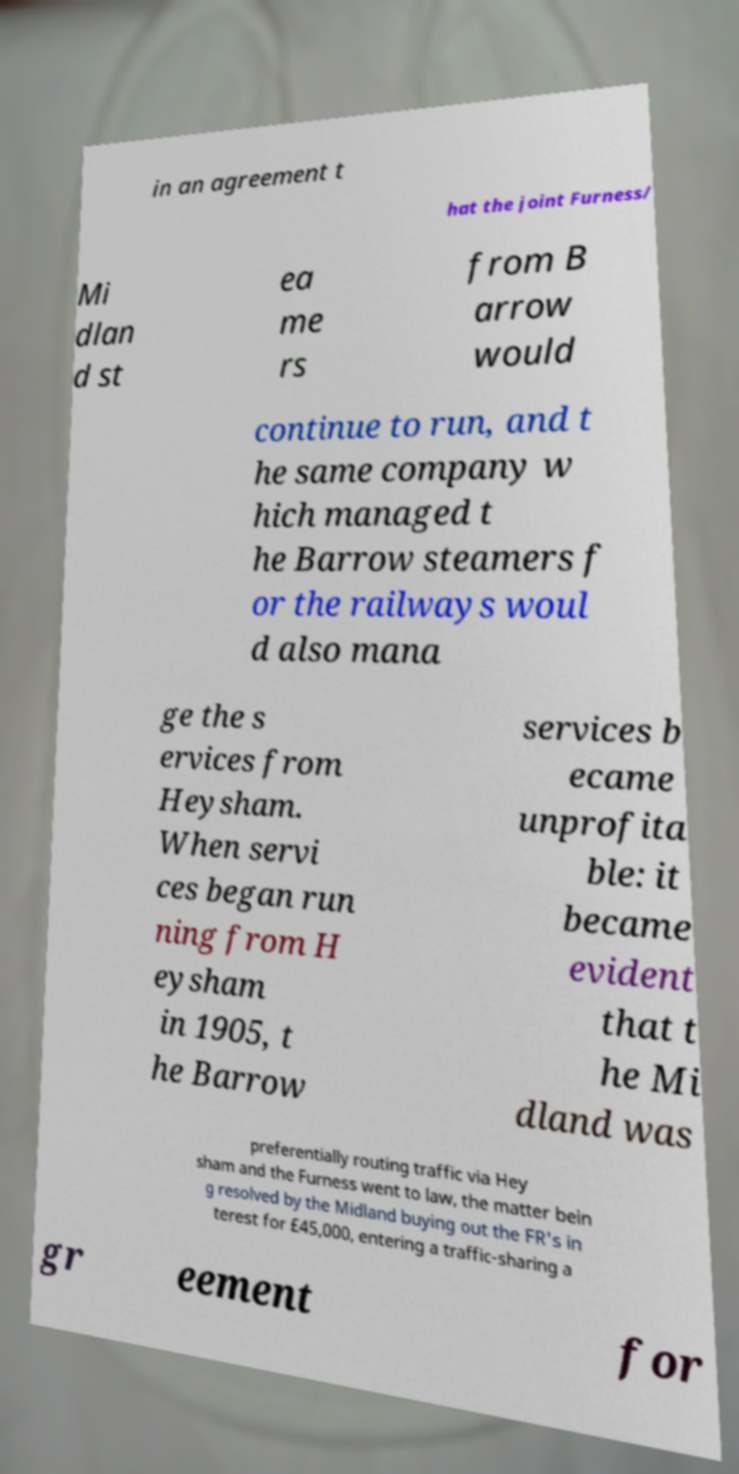Can you read and provide the text displayed in the image?This photo seems to have some interesting text. Can you extract and type it out for me? in an agreement t hat the joint Furness/ Mi dlan d st ea me rs from B arrow would continue to run, and t he same company w hich managed t he Barrow steamers f or the railways woul d also mana ge the s ervices from Heysham. When servi ces began run ning from H eysham in 1905, t he Barrow services b ecame unprofita ble: it became evident that t he Mi dland was preferentially routing traffic via Hey sham and the Furness went to law, the matter bein g resolved by the Midland buying out the FR's in terest for £45,000, entering a traffic-sharing a gr eement for 